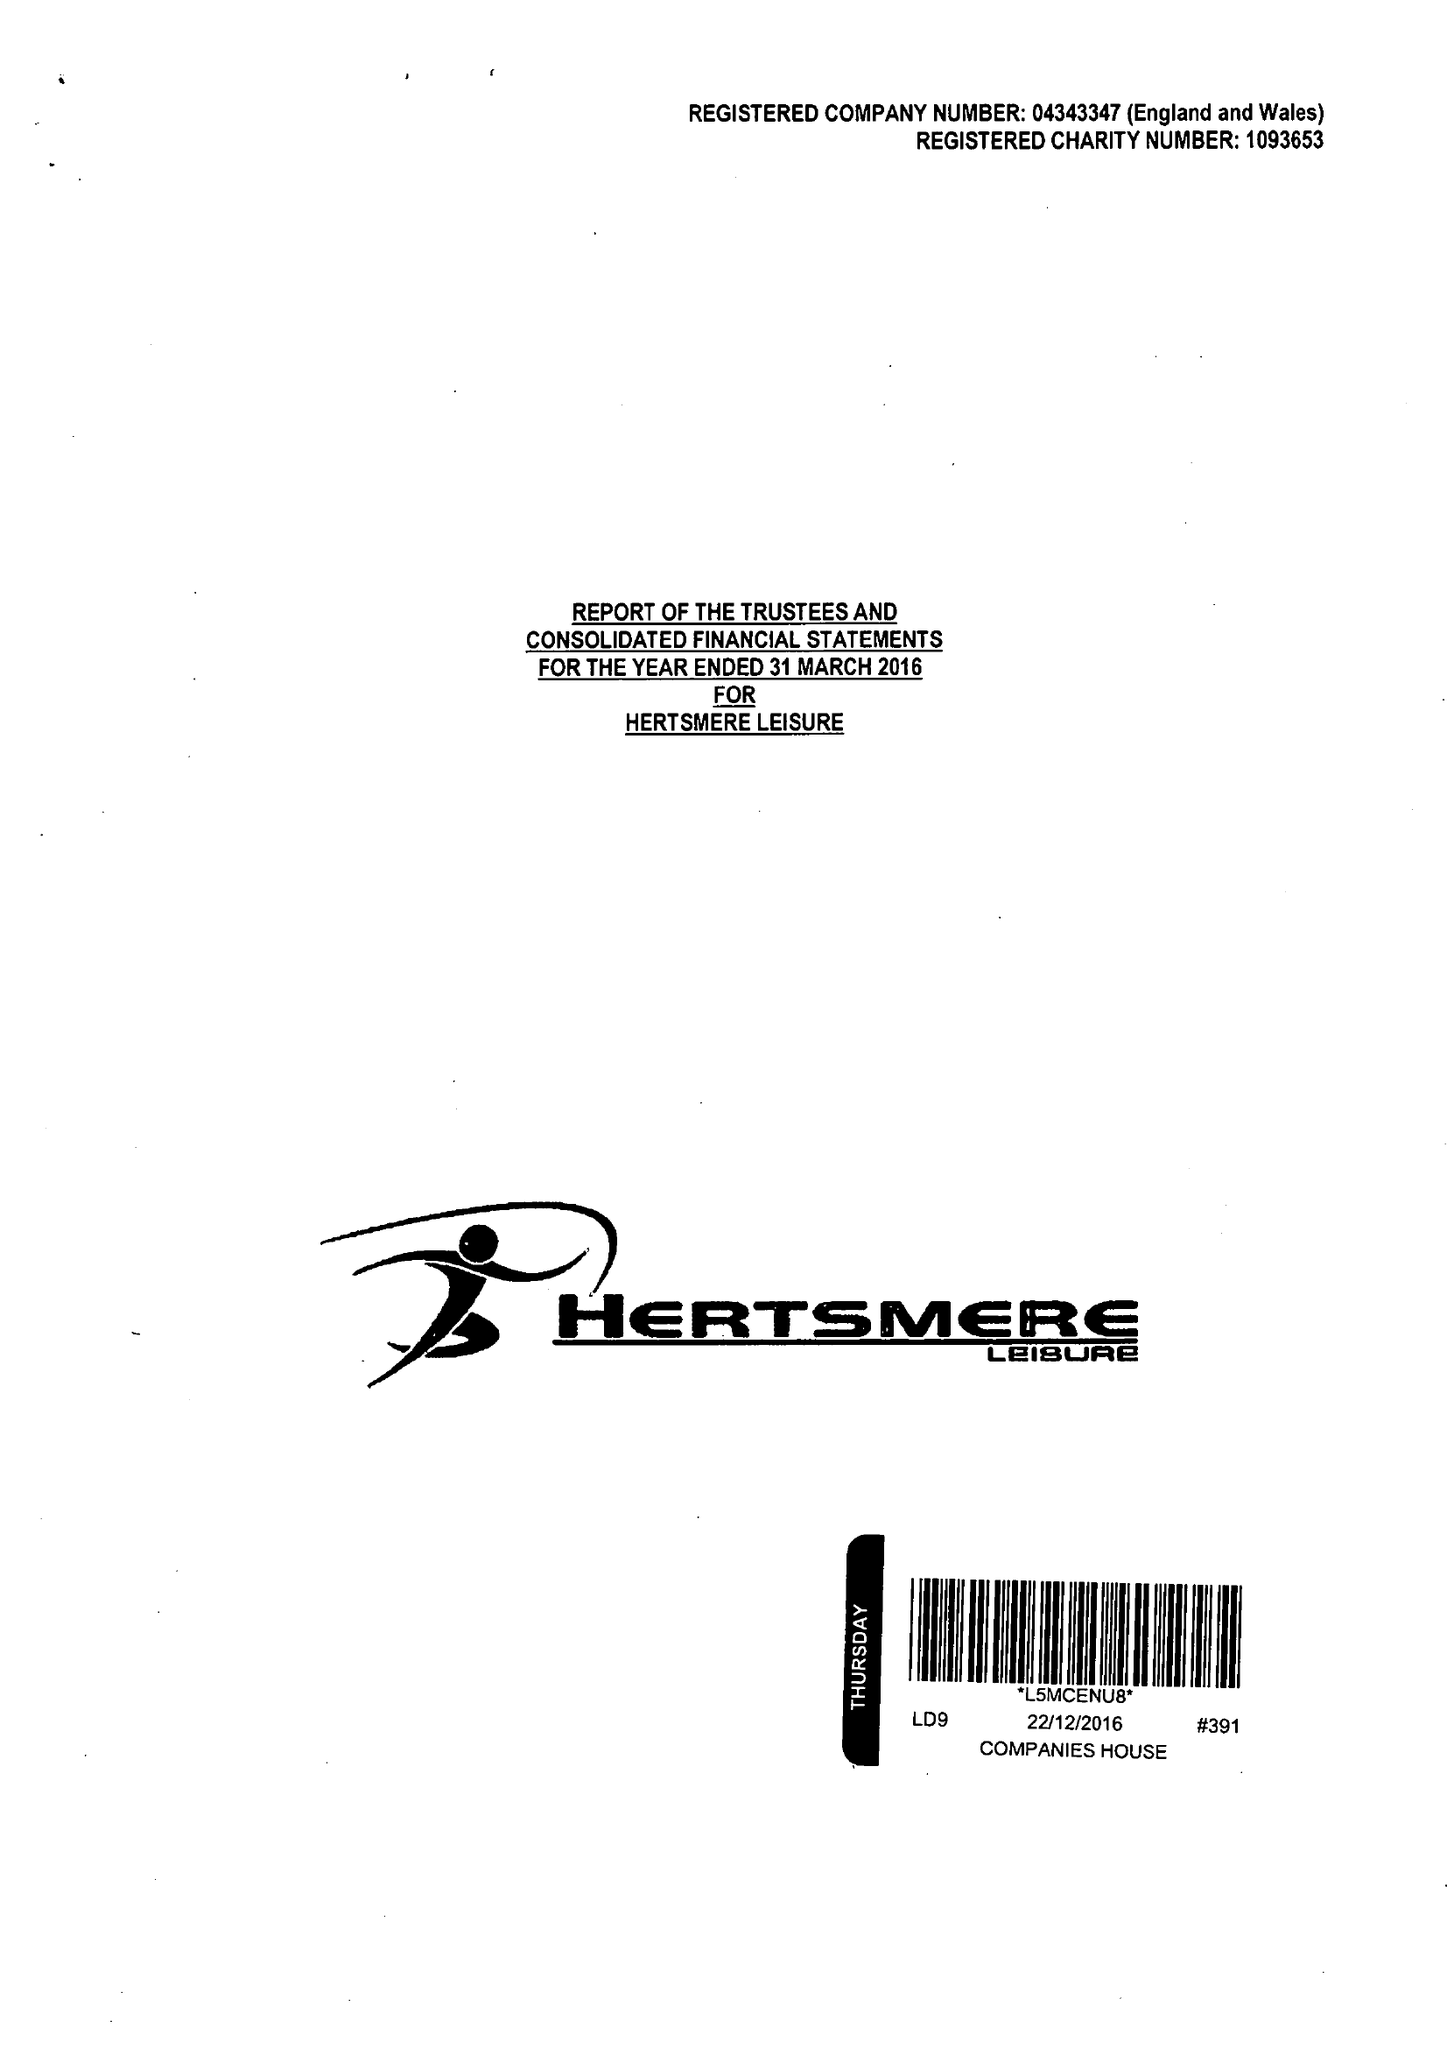What is the value for the address__street_line?
Answer the question using a single word or phrase. ELSTREE WAY 